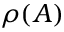Convert formula to latex. <formula><loc_0><loc_0><loc_500><loc_500>\rho ( A )</formula> 